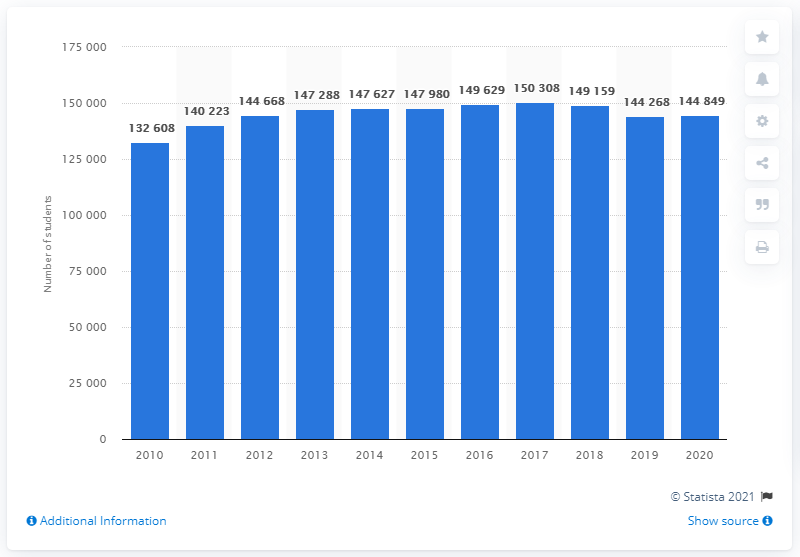Point out several critical features in this image. There were 144,849 upper secondary students in Denmark in 2020. In 2009, there were 132,608 upper secondary students in Denmark. 